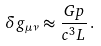<formula> <loc_0><loc_0><loc_500><loc_500>\delta g _ { \mu \nu } \approx \frac { G p } { c ^ { 3 } L } \, .</formula> 